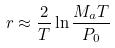<formula> <loc_0><loc_0><loc_500><loc_500>r \approx \frac { 2 } { T } \ln \frac { M _ { a } T } { P _ { 0 } }</formula> 